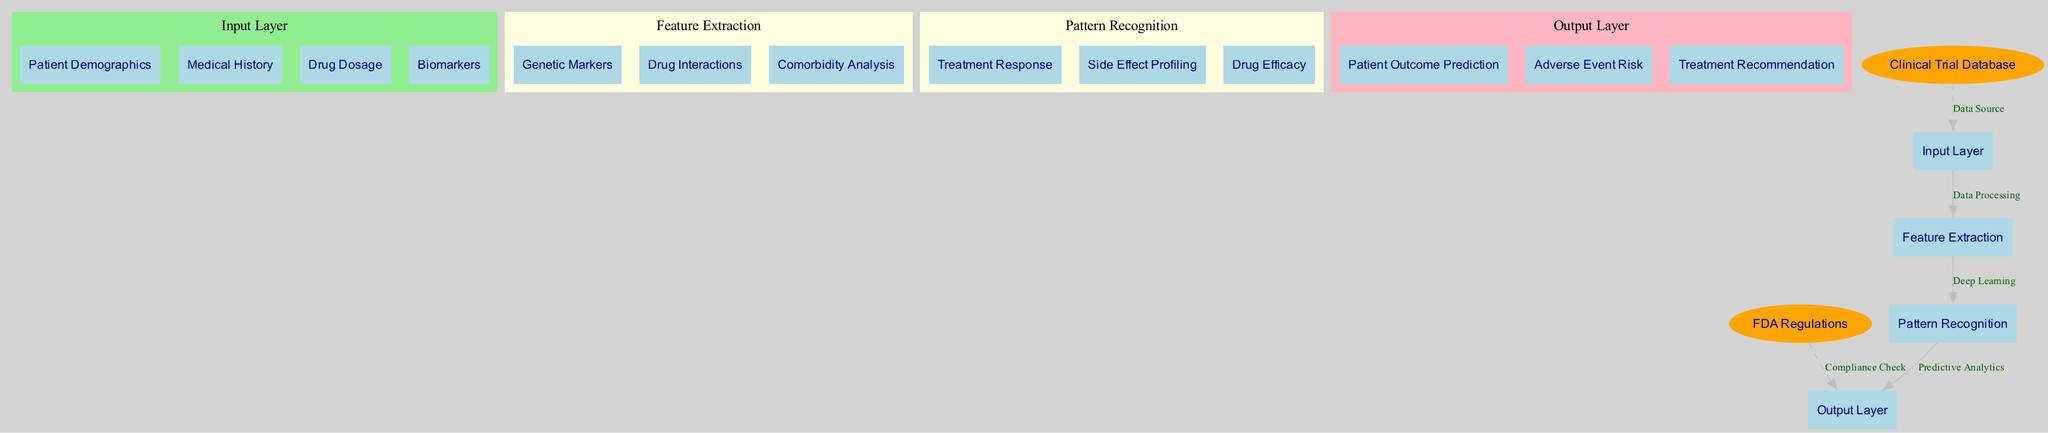What are the nodes in the input layer? The input layer contains four nodes representing key inputs necessary for predictions: Patient Demographics, Medical History, Drug Dosage, and Biomarkers.
Answer: Patient Demographics, Medical History, Drug Dosage, Biomarkers How many hidden layers are in this neural network? The diagram has two hidden layers: Feature Extraction and Pattern Recognition. Counting these provides the total number.
Answer: 2 What is the output of the neural network? The output layer has three nodes which indicate what the neural network predicts: Patient Outcome Prediction, Adverse Event Risk, and Treatment Recommendation.
Answer: Patient Outcome Prediction, Adverse Event Risk, Treatment Recommendation What does the edge labeled "Data Processing" connect? "Data Processing" connects the Input Layer to the Feature Extraction hidden layer, indicating the flow of data from the inputs to initial feature extraction.
Answer: Input Layer to Feature Extraction What is the role of the "Clinical Trial Database"? The Clinical Trial Database acts as a data source for the input layer, providing essential data for the model to analyze patient outcomes.
Answer: Data Source Which hidden layer focuses on analyzing Treatment Response? The Treatment Response analysis occurs in the Pattern Recognition hidden layer, which is responsible for identifying treatment effects among patients.
Answer: Pattern Recognition How many nodes are in the "Feature Extraction" layer? The Feature Extraction layer consists of three nodes: Genetic Markers, Drug Interactions, and Comorbidity Analysis, indicating different aspects of data processed here.
Answer: 3 What is the nature of the connection from the output layer to FDA Regulations? This connection is dashed and labeled as "Compliance Check," underscoring the regulatory oversight required for outcomes predicted by the neural network.
Answer: Compliance Check What type of learning occurs between Feature Extraction and Pattern Recognition? The edge between Feature Extraction and Pattern Recognition is labeled "Deep Learning," signifying the advanced data processing involved in this layer transition.
Answer: Deep Learning 